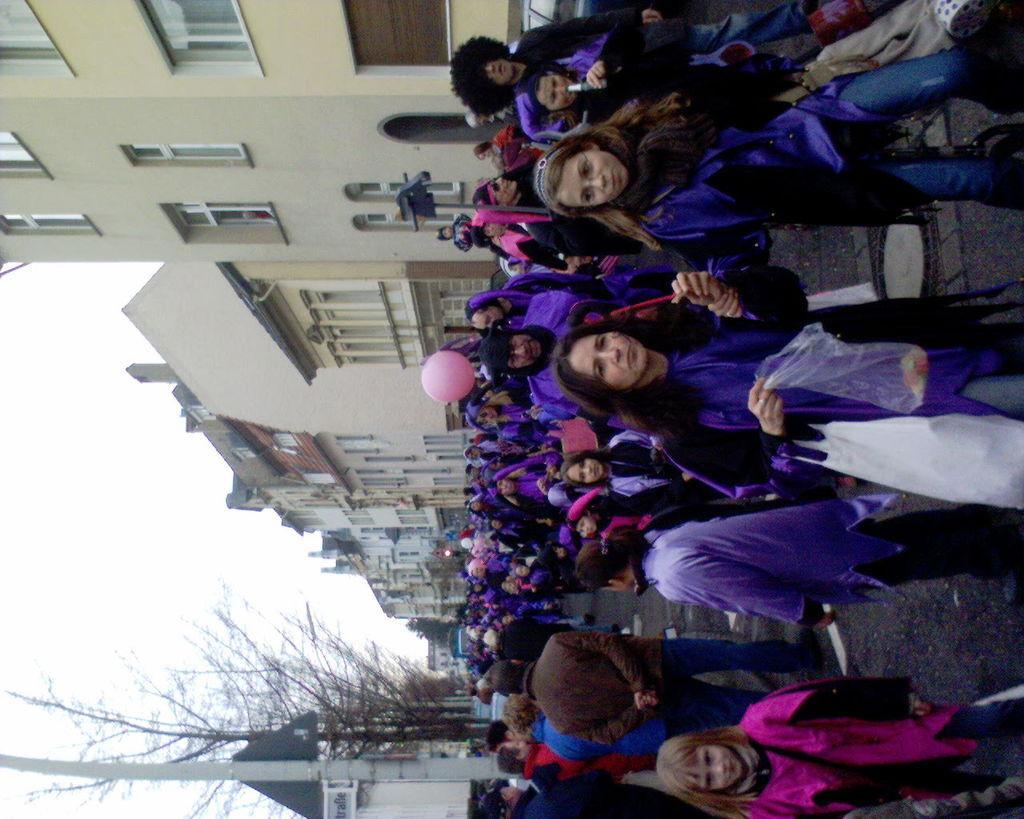In one or two sentences, can you explain what this image depicts? This image is in left direction. On the right side, I can see many people are standing on the road. In the background there are some buildings and trees. On the left side, I can see the sky. 